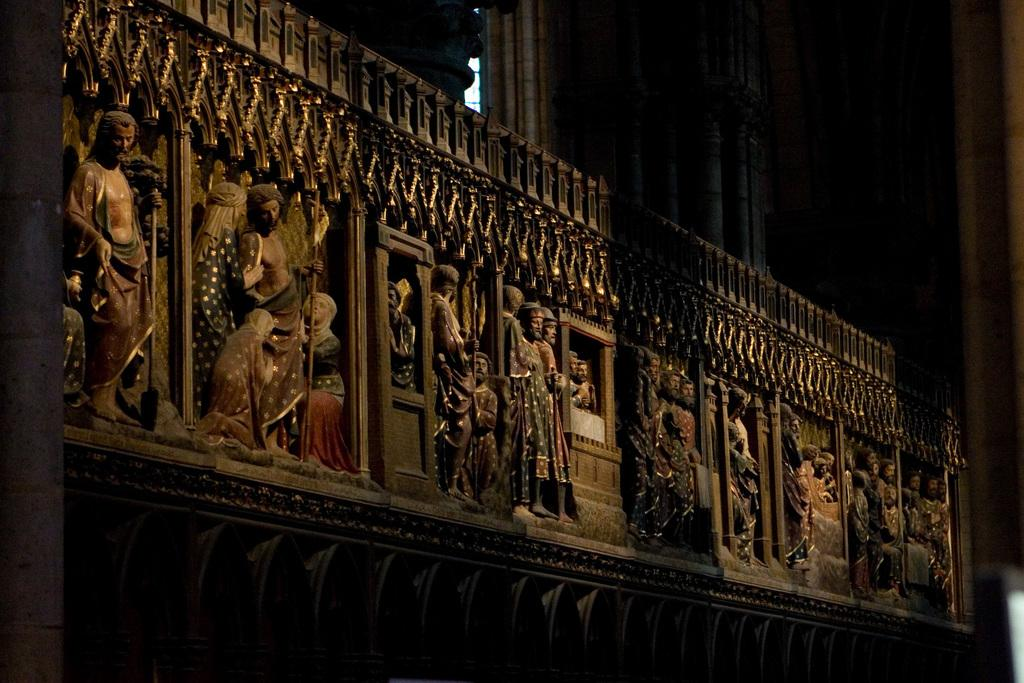What type of art is present in the image? There are sculptures in the image. Where are the sculptures located? The sculptures are on a platform. Can you describe the background of the image? The background of the image is not clear. What type of toothbrush is being used by the duck in the image? There is no toothbrush or duck present in the image. 